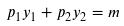<formula> <loc_0><loc_0><loc_500><loc_500>p _ { 1 } y _ { 1 } + p _ { 2 } y _ { 2 } = m</formula> 